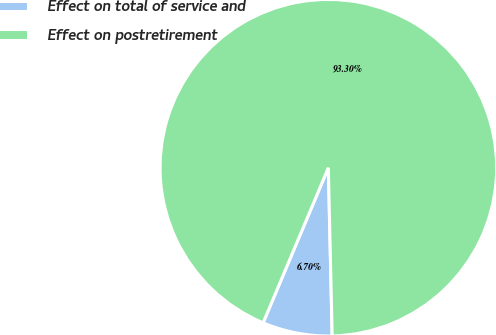Convert chart to OTSL. <chart><loc_0><loc_0><loc_500><loc_500><pie_chart><fcel>Effect on total of service and<fcel>Effect on postretirement<nl><fcel>6.7%<fcel>93.3%<nl></chart> 